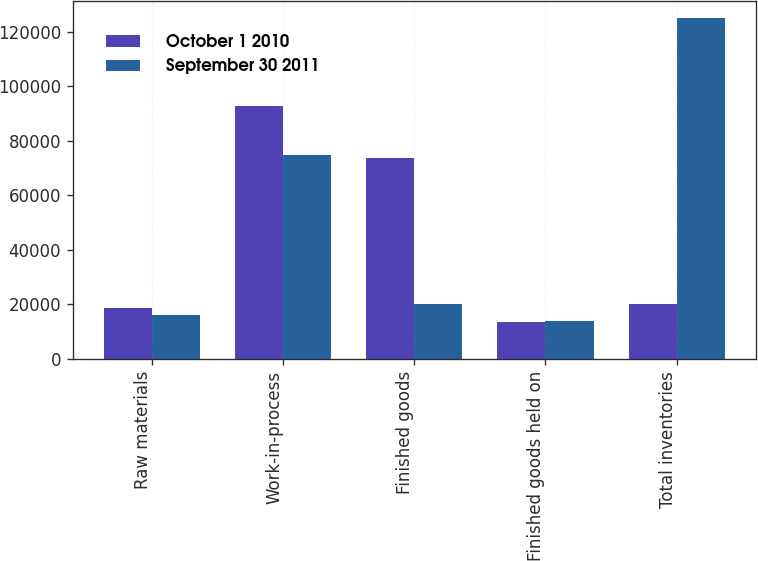Convert chart to OTSL. <chart><loc_0><loc_0><loc_500><loc_500><stacked_bar_chart><ecel><fcel>Raw materials<fcel>Work-in-process<fcel>Finished goods<fcel>Finished goods held on<fcel>Total inventories<nl><fcel>October 1 2010<fcel>18565<fcel>92601<fcel>73633<fcel>13384<fcel>20209<nl><fcel>September 30 2011<fcel>16108<fcel>74701<fcel>20209<fcel>14041<fcel>125059<nl></chart> 